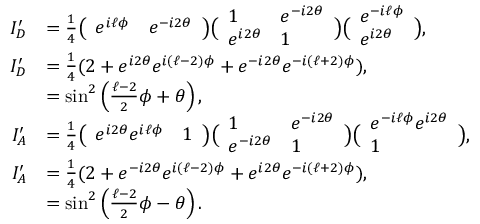Convert formula to latex. <formula><loc_0><loc_0><loc_500><loc_500>\begin{array} { r l } { I _ { D } ^ { \prime } } & { = \frac { 1 } { 4 } \left ( \begin{array} { l l } { e ^ { i \ell \phi } } & { e ^ { - i 2 \theta } } \end{array} \right ) \left ( \begin{array} { l l } { 1 } & { e ^ { - i 2 \theta } } \\ { e ^ { i 2 \theta } } & { 1 } \end{array} \right ) \left ( \begin{array} { l } { e ^ { - i \ell \phi } } \\ { e ^ { i 2 \theta } } \end{array} \right ) , } \\ { I _ { D } ^ { \prime } } & { = \frac { 1 } { 4 } ( 2 + e ^ { i 2 \theta } e ^ { i ( \ell - 2 ) \phi } + e ^ { - i 2 \theta } e ^ { - i ( \ell + 2 ) \phi } ) , } \\ & { = \sin ^ { 2 } \left ( \frac { \ell - 2 } { 2 } \phi + \theta \right ) , \ } \\ { I _ { A } ^ { \prime } } & { = \frac { 1 } { 4 } \left ( \begin{array} { l l } { e ^ { i 2 \theta } e ^ { i \ell \phi } } & { 1 } \end{array} \right ) \left ( \begin{array} { l l } { 1 } & { e ^ { - i 2 \theta } } \\ { e ^ { - i 2 \theta } } & { 1 } \end{array} \right ) \left ( \begin{array} { l } { e ^ { - i \ell \phi } e ^ { i 2 \theta } } \\ { 1 } \end{array} \right ) , } \\ { I _ { A } ^ { \prime } } & { = \frac { 1 } { 4 } ( 2 + e ^ { - i 2 \theta } e ^ { i ( \ell - 2 ) \phi } + e ^ { i 2 \theta } e ^ { - i ( \ell + 2 ) \phi } ) , } \\ & { = \sin ^ { 2 } \left ( \frac { \ell - 2 } { 2 } \phi - \theta \right ) . } \end{array}</formula> 